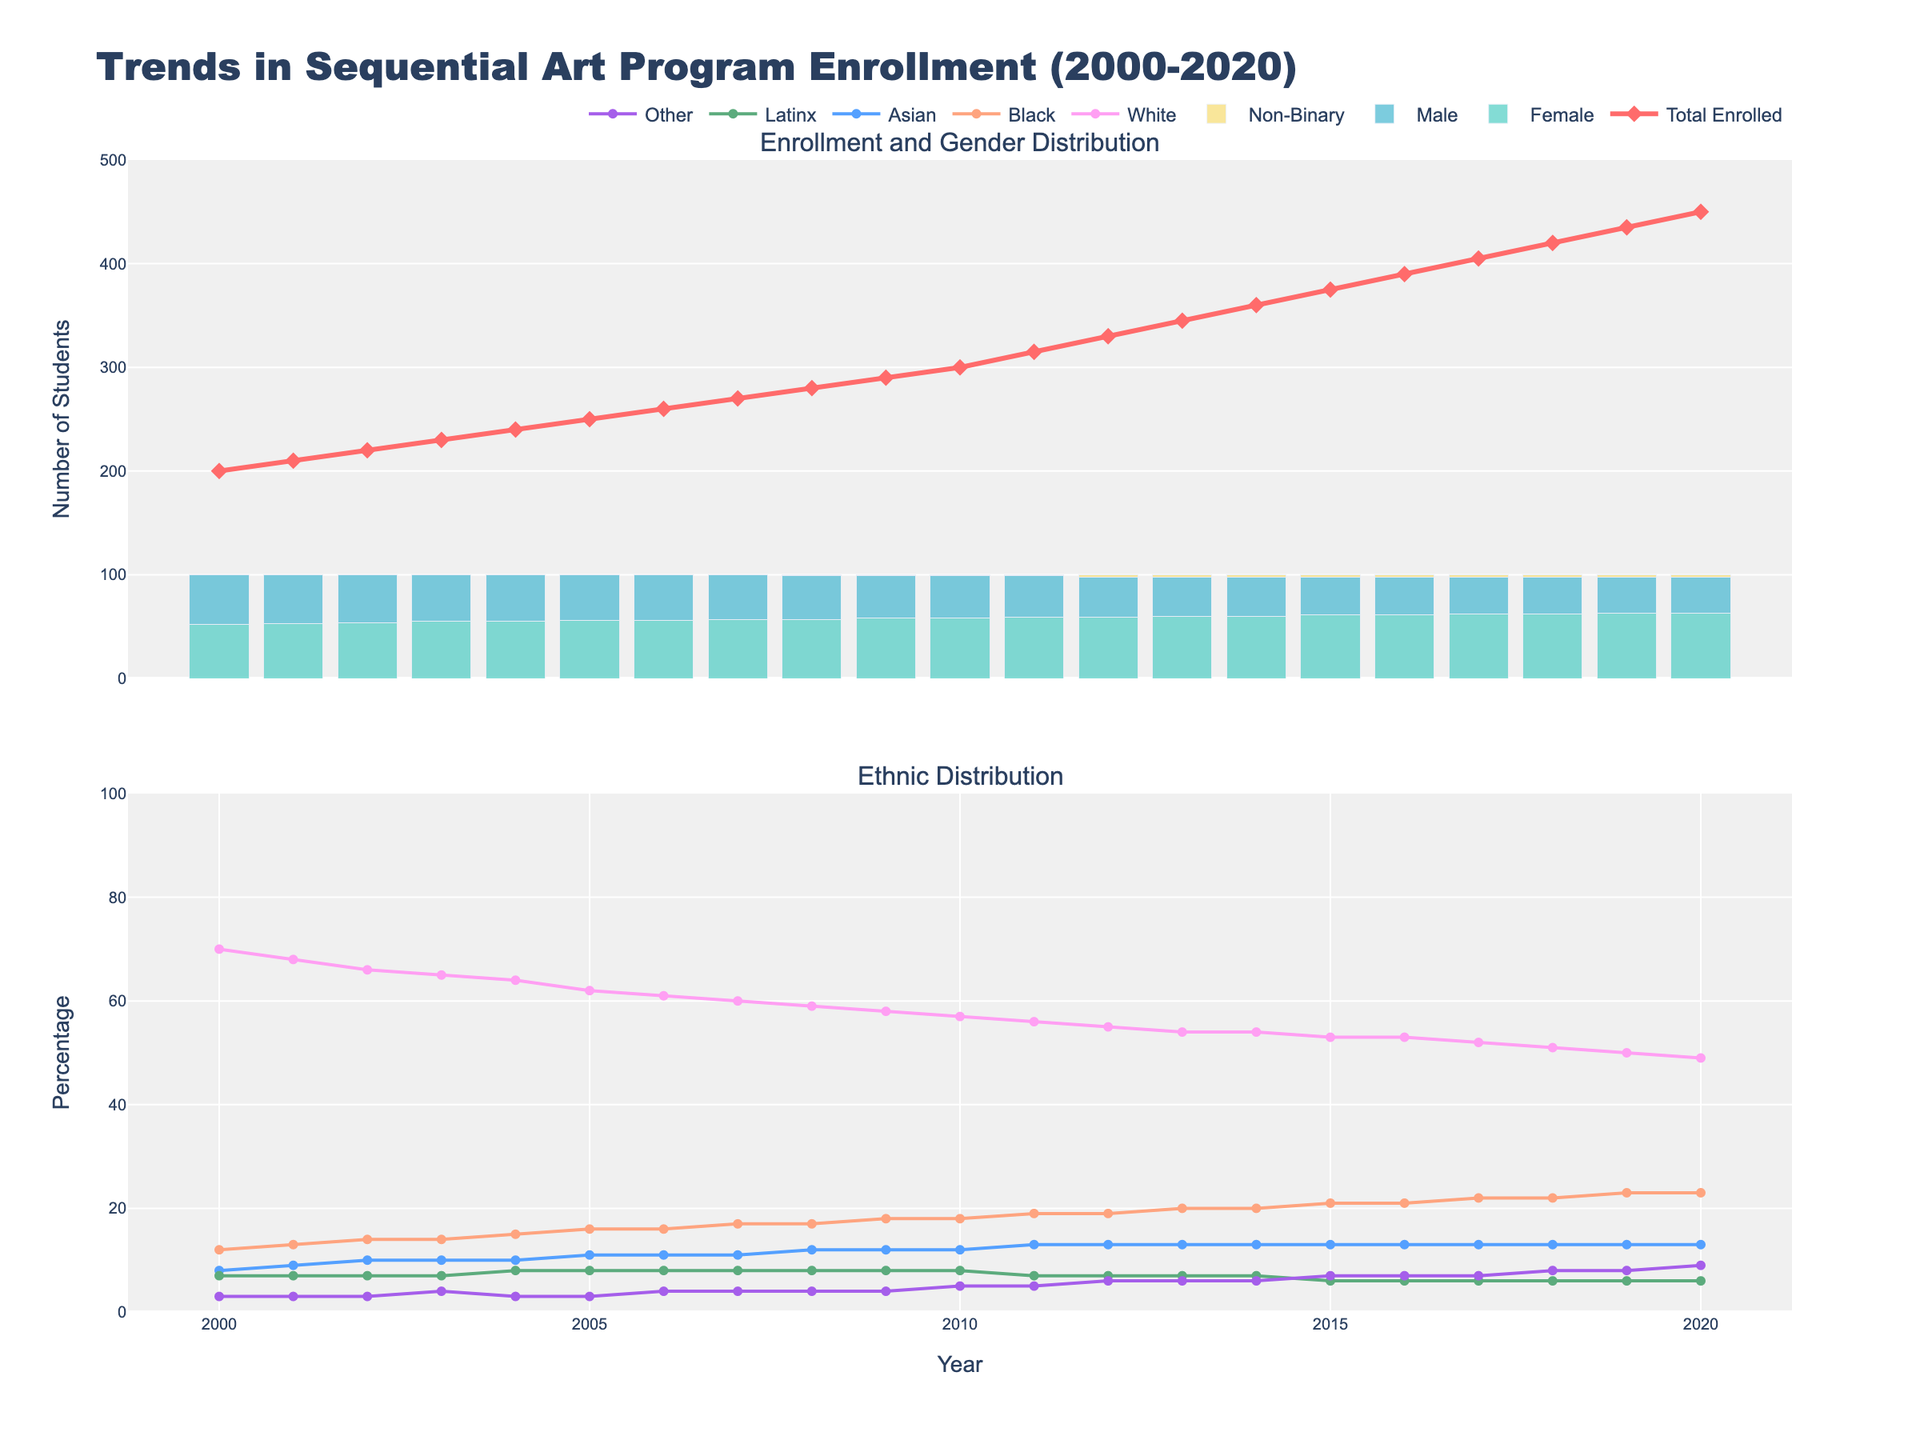What is the total number of students enrolled in 2020? The top subplot shows the "Total Enrolled" as a line plot. Looking at the endpoint of the red line in 2020, we can count the number of students.
Answer: 450 What is the trend in the percentage of female students from 2000 to 2020? The top subplot contains a bar plot of the percent female students. Observing the heights of the green bars from 2000 to 2020, we notice an upward trend.
Answer: Increasing Which year had the highest percentage of male students? In the top subplot, the blue bars represent male student percentages. By identifying the tallest blue bar, we see that 2000 shows the highest percentage.
Answer: 2000 How has the percentage of international students changed over the years? The percentage of international students is shown in the top subplot in varying colors. Noting the height from one year to the next, there is a gradual increase over the period.
Answer: Increased Which ethnicity has consistently had the lowest percentage of students enrolled? In the bottom subplot, different lines represent different ethnicities. Observing the lowest line across years, we can identify the ethnicity with the smallest percentage.
Answer: Other What is the average total enrollment from 2000 to 2020? Summing up the "Total Enrolled" from 2000 to 2020 and dividing by the number of years (21) gives us the average. The total sum is 7055 and the average is 7055/21.
Answer: 335.5 In what year did non-binary students start being recorded and what was their percentage? The top subplot shows the percentage of non-binary students recorded only after 2008. The height of the yellow bar in 2008 indicates the percentage.
Answer: 2008, 1% Compare the percentage of Black and Asian students in 2015. Which is higher? In the bottom subplot, identifying the Black and Asian students' lines at the 2015 mark, we see that the line for Black students is higher than the line for Asian students.
Answer: Black Did the percentage of Latinx students increase or decrease from 2010 to 2020? Observing the purple line in the bottom subplot from 2010 to 2020, we can see an initial dip and then a slight upward trend, overall.
Answer: Increase Which year saw the biggest drop in the percentage of White students? Reviewing the pink line in the bottom subplot representing White students, the year-to-year decrease is the most significant between 2019 and 2020.
Answer: 2019 to 2020 